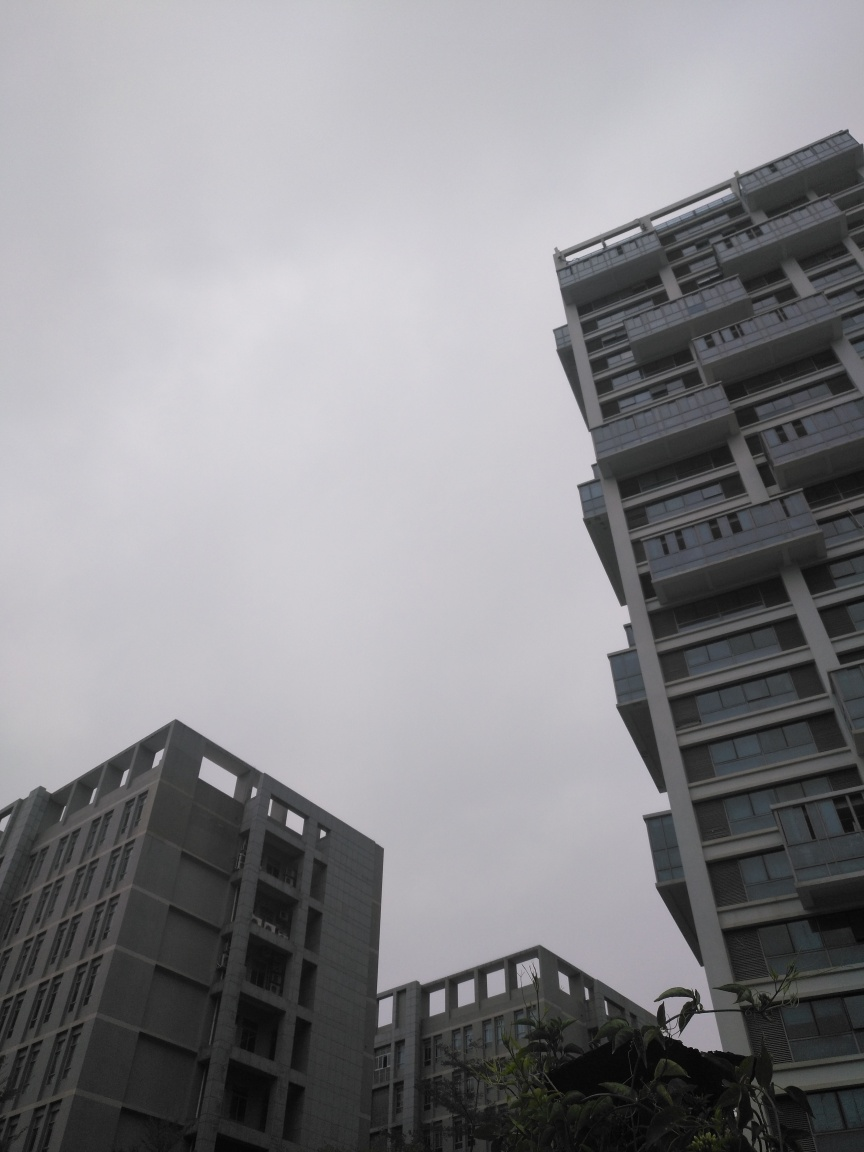Explore the quality factors of the image and offer an evaluation based on your insights.
 The outline structure of the building in this picture is very clear, and the composition is very good, giving people a sense of grandeur. Therefore, the quality of this picture is relatively good. 